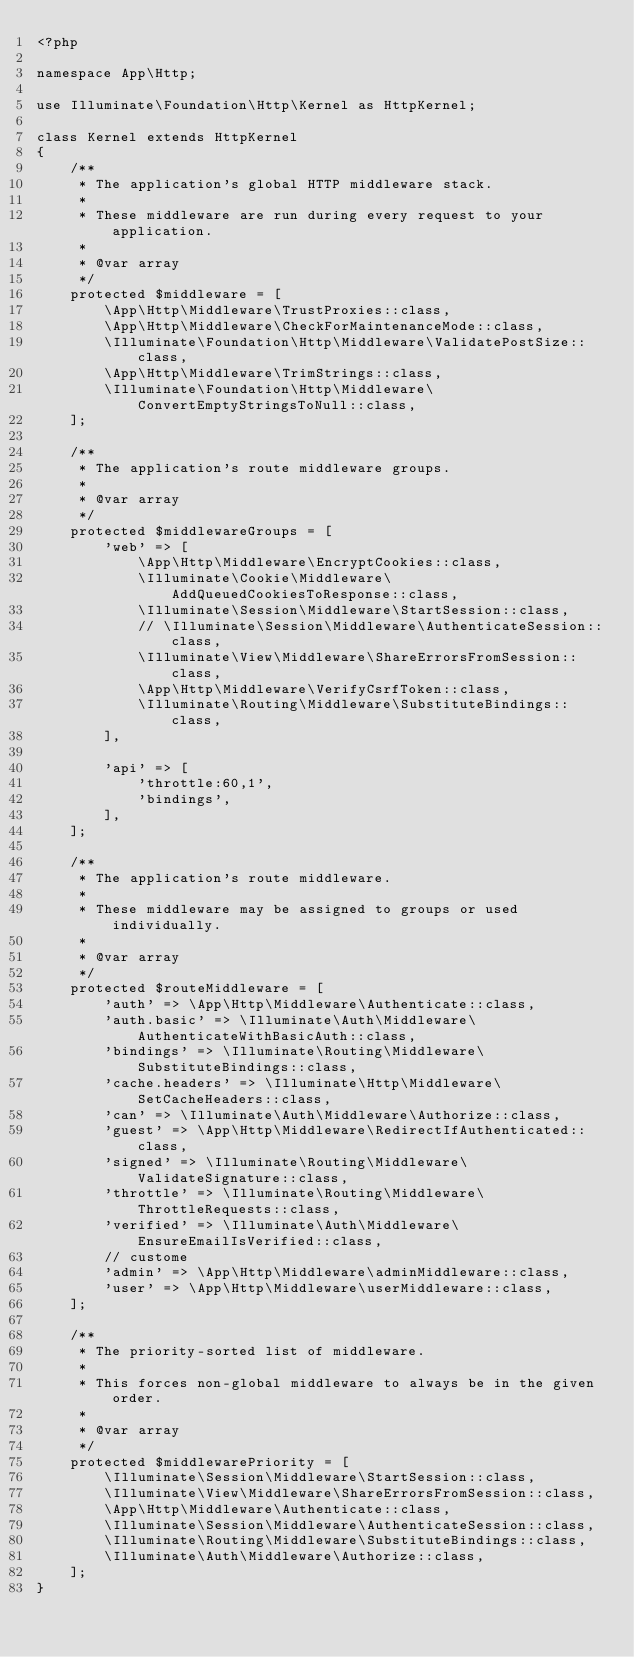Convert code to text. <code><loc_0><loc_0><loc_500><loc_500><_PHP_><?php

namespace App\Http;

use Illuminate\Foundation\Http\Kernel as HttpKernel;

class Kernel extends HttpKernel
{
    /**
     * The application's global HTTP middleware stack.
     *
     * These middleware are run during every request to your application.
     *
     * @var array
     */
    protected $middleware = [
        \App\Http\Middleware\TrustProxies::class,
        \App\Http\Middleware\CheckForMaintenanceMode::class,
        \Illuminate\Foundation\Http\Middleware\ValidatePostSize::class,
        \App\Http\Middleware\TrimStrings::class,
        \Illuminate\Foundation\Http\Middleware\ConvertEmptyStringsToNull::class,
    ];

    /**
     * The application's route middleware groups.
     *
     * @var array
     */
    protected $middlewareGroups = [
        'web' => [
            \App\Http\Middleware\EncryptCookies::class,
            \Illuminate\Cookie\Middleware\AddQueuedCookiesToResponse::class,
            \Illuminate\Session\Middleware\StartSession::class,
            // \Illuminate\Session\Middleware\AuthenticateSession::class,
            \Illuminate\View\Middleware\ShareErrorsFromSession::class,
            \App\Http\Middleware\VerifyCsrfToken::class,
            \Illuminate\Routing\Middleware\SubstituteBindings::class,
        ],

        'api' => [
            'throttle:60,1',
            'bindings',
        ],
    ];

    /**
     * The application's route middleware.
     *
     * These middleware may be assigned to groups or used individually.
     *
     * @var array
     */
    protected $routeMiddleware = [
        'auth' => \App\Http\Middleware\Authenticate::class,
        'auth.basic' => \Illuminate\Auth\Middleware\AuthenticateWithBasicAuth::class,
        'bindings' => \Illuminate\Routing\Middleware\SubstituteBindings::class,
        'cache.headers' => \Illuminate\Http\Middleware\SetCacheHeaders::class,
        'can' => \Illuminate\Auth\Middleware\Authorize::class,
        'guest' => \App\Http\Middleware\RedirectIfAuthenticated::class,
        'signed' => \Illuminate\Routing\Middleware\ValidateSignature::class,
        'throttle' => \Illuminate\Routing\Middleware\ThrottleRequests::class,
        'verified' => \Illuminate\Auth\Middleware\EnsureEmailIsVerified::class,
        // custome
        'admin' => \App\Http\Middleware\adminMiddleware::class,
        'user' => \App\Http\Middleware\userMiddleware::class,
    ];

    /**
     * The priority-sorted list of middleware.
     *
     * This forces non-global middleware to always be in the given order.
     *
     * @var array
     */
    protected $middlewarePriority = [
        \Illuminate\Session\Middleware\StartSession::class,
        \Illuminate\View\Middleware\ShareErrorsFromSession::class,
        \App\Http\Middleware\Authenticate::class,
        \Illuminate\Session\Middleware\AuthenticateSession::class,
        \Illuminate\Routing\Middleware\SubstituteBindings::class,
        \Illuminate\Auth\Middleware\Authorize::class,
    ];
}
</code> 